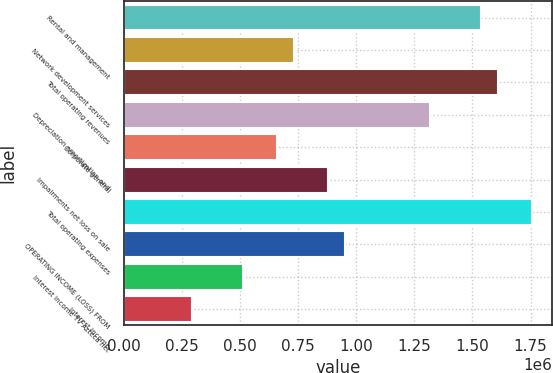Convert chart to OTSL. <chart><loc_0><loc_0><loc_500><loc_500><bar_chart><fcel>Rental and management<fcel>Network development services<fcel>Total operating revenues<fcel>Depreciation amortization and<fcel>Corporate general<fcel>Impairments net loss on sale<fcel>Total operating expenses<fcel>OPERATING INCOME (LOSS) FROM<fcel>Interest income TV Azteca net<fcel>Interest income<nl><fcel>1.53569e+06<fcel>731281<fcel>1.60882e+06<fcel>1.3163e+06<fcel>658153<fcel>877537<fcel>1.75507e+06<fcel>950665<fcel>511897<fcel>292513<nl></chart> 